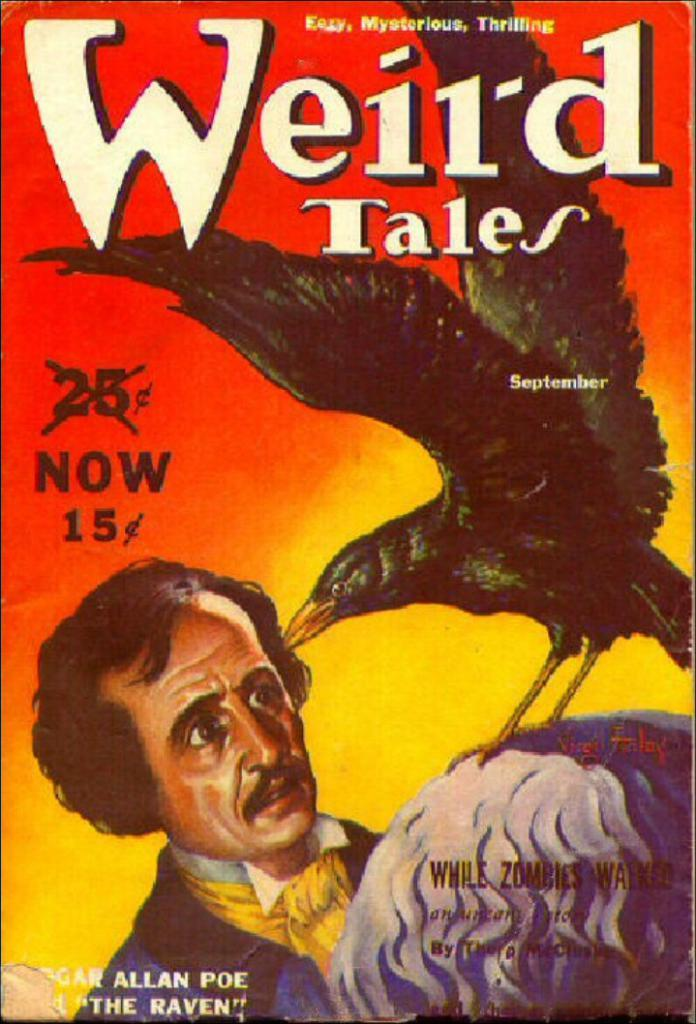Provide a one-sentence caption for the provided image. The cover of Weird Tales has an orange and yellow background. 